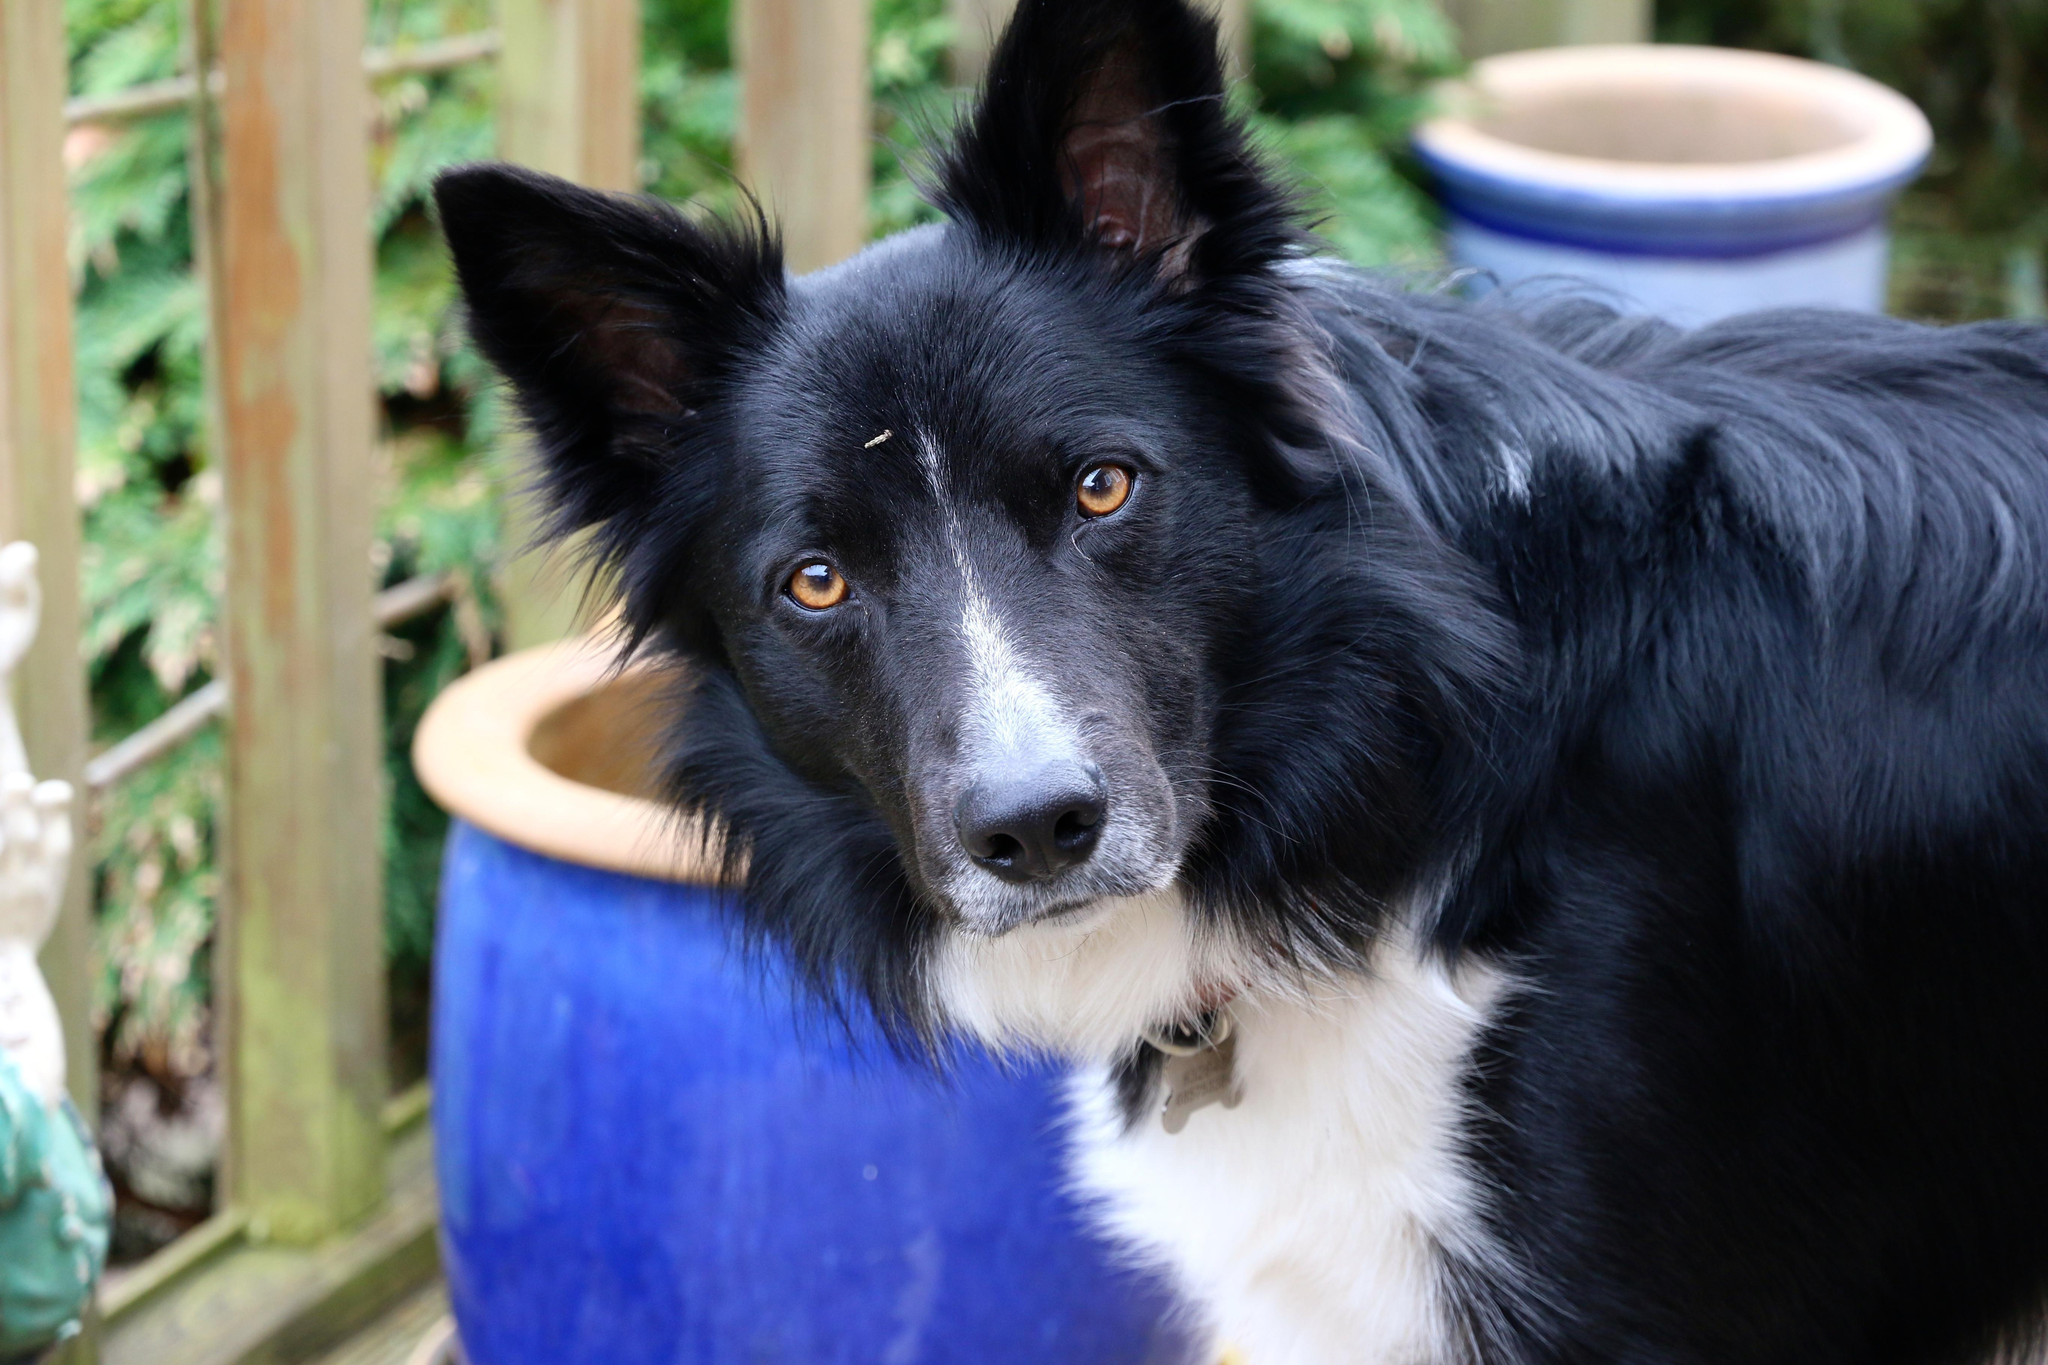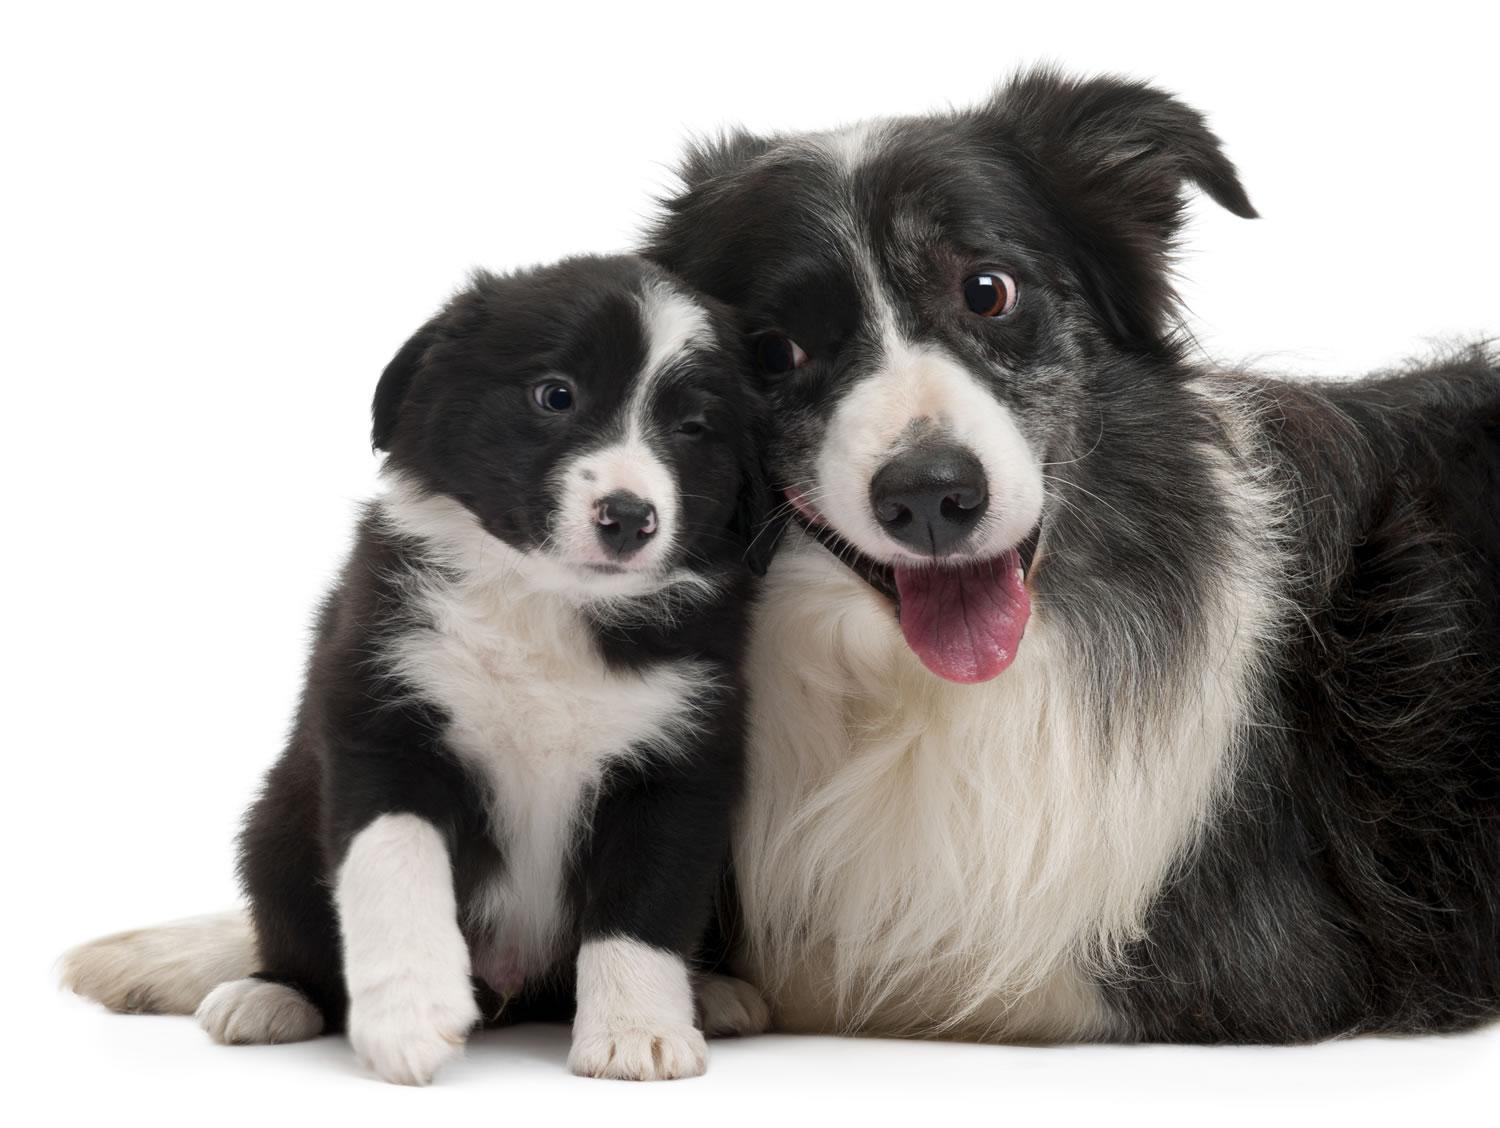The first image is the image on the left, the second image is the image on the right. For the images shown, is this caption "There are two animals" true? Answer yes or no. No. The first image is the image on the left, the second image is the image on the right. For the images displayed, is the sentence "One image shows two animals side-by-side with a plain backdrop." factually correct? Answer yes or no. Yes. 